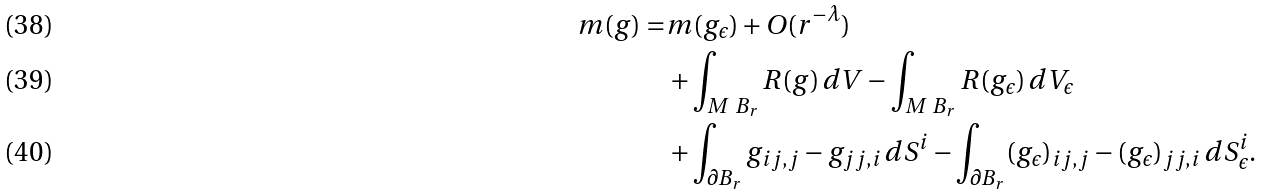<formula> <loc_0><loc_0><loc_500><loc_500>m ( g ) = & m ( g _ { \epsilon } ) + O ( r ^ { - \lambda } ) \\ & + \int _ { M \ B _ { r } } R ( g ) \, d V - \int _ { M \ B _ { r } } R ( g _ { \epsilon } ) \, d V _ { \epsilon } \\ & + \int _ { \partial B _ { r } } g _ { i j , j } - g _ { j j , i } \, d S ^ { i } - \int _ { \partial B _ { r } } ( g _ { \epsilon } ) _ { i j , j } - ( g _ { \epsilon } ) _ { j j , i } \, d S _ { \epsilon } ^ { i } .</formula> 